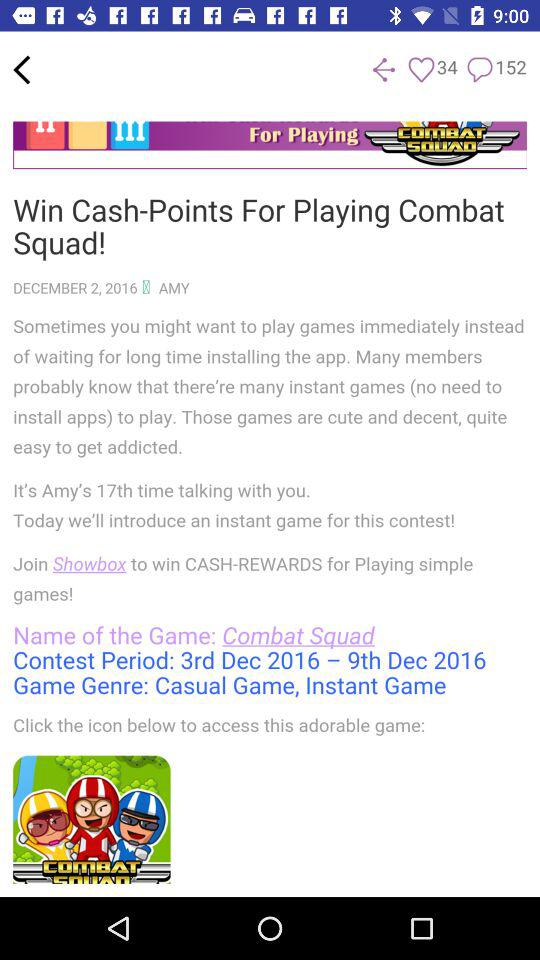What is the genre of the game? The genre of the game is casual and instant. 